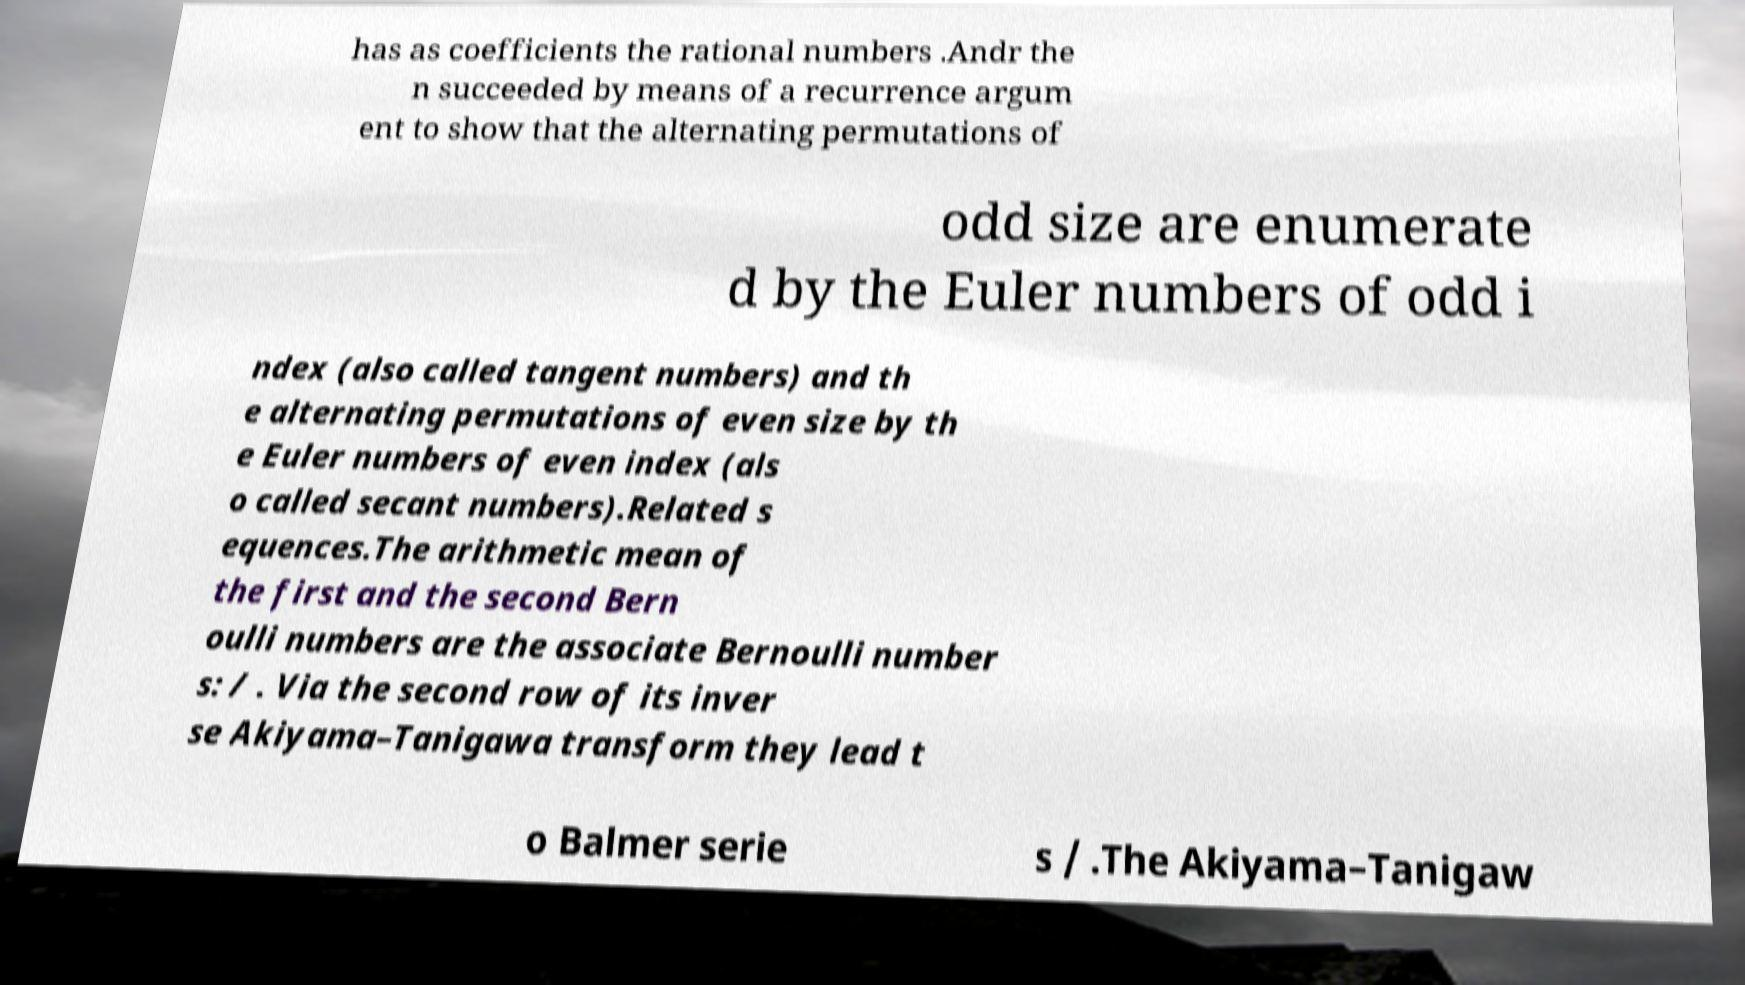Please identify and transcribe the text found in this image. has as coefficients the rational numbers .Andr the n succeeded by means of a recurrence argum ent to show that the alternating permutations of odd size are enumerate d by the Euler numbers of odd i ndex (also called tangent numbers) and th e alternating permutations of even size by th e Euler numbers of even index (als o called secant numbers).Related s equences.The arithmetic mean of the first and the second Bern oulli numbers are the associate Bernoulli number s: / . Via the second row of its inver se Akiyama–Tanigawa transform they lead t o Balmer serie s / .The Akiyama–Tanigaw 